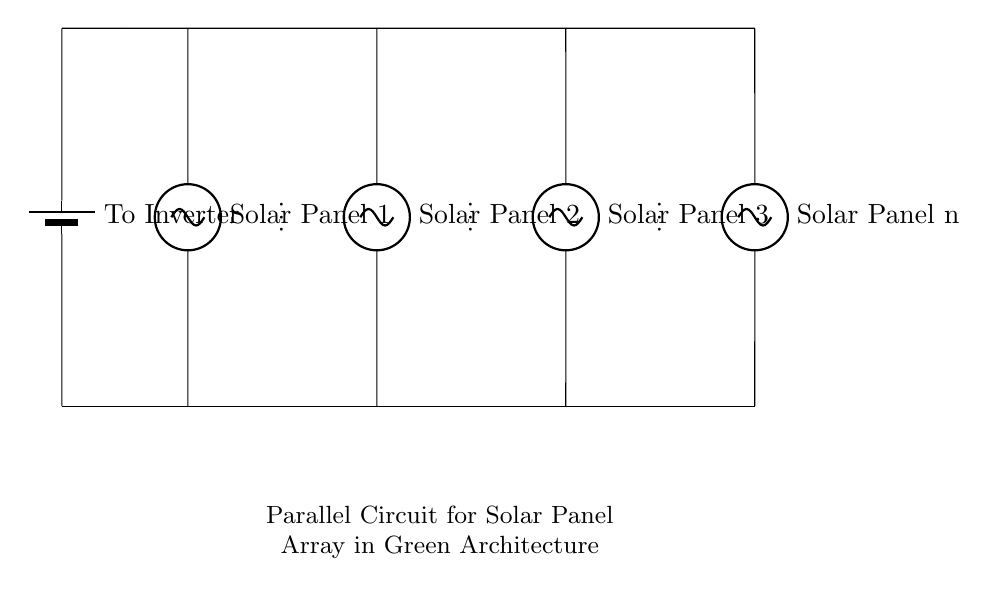What do the components in this circuit represent? The components are solar panels connected in parallel, each represented as a symbol (sV) which stands for solar voltage sources.
Answer: solar panels What is the purpose of the inverter in this circuit? The inverter converts the direct current produced by the solar panels into alternating current, making it suitable for use with electrical systems.
Answer: conversion of current How many solar panels are shown in this diagram? There are multiple solar panel symbols in the diagram, which typically can be counted individually or noted as a variable across the entire circuit. The diagram includes identifiers for at least three panels and refers to additional panels, indicating the total number is n.
Answer: n panels What type of circuit configuration is displayed here? The circuit configuration is specifically designed to connect solar panels in a parallel arrangement, which allows for independent current flow through each panel.
Answer: parallel configuration What is the voltage output of this solar panel array? In a parallel circuit, the voltage across each panel remains the same as the voltage rating of an individual panel, meaning the total voltage output is equal to the voltage of one panel.
Answer: same as one panel's voltage 